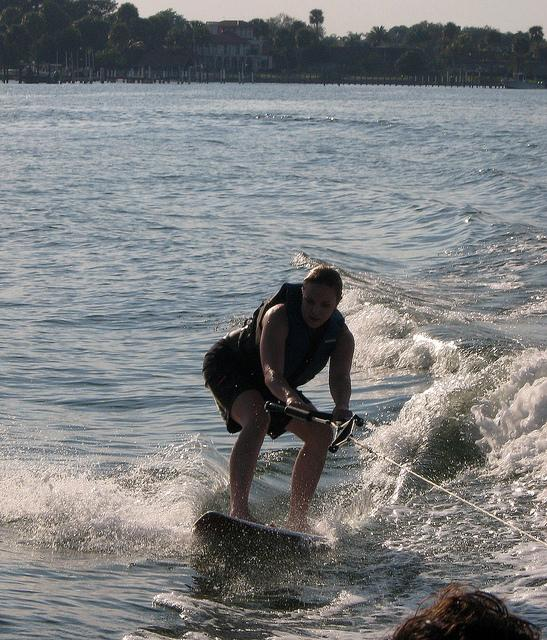What is the name of the safety garment the wakeboarder is wearing? life jacket 